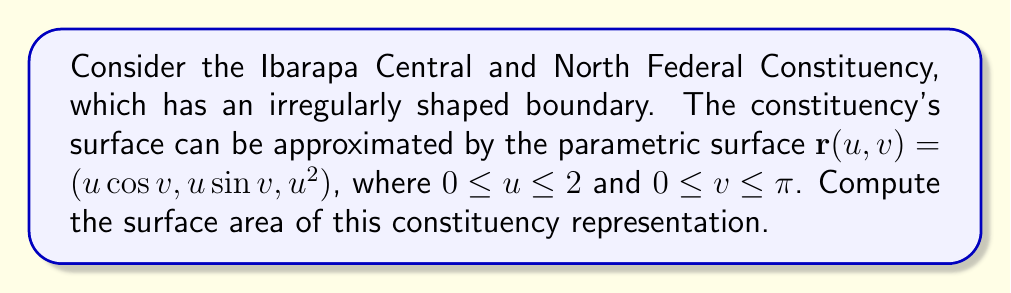Provide a solution to this math problem. To compute the surface area of the parametric surface, we follow these steps:

1) The formula for the surface area of a parametric surface is:

   $$A = \int\int_D \left|\frac{\partial \mathbf{r}}{\partial u} \times \frac{\partial \mathbf{r}}{\partial v}\right| du dv$$

2) Calculate the partial derivatives:
   
   $$\frac{\partial \mathbf{r}}{\partial u} = (\cos v, \sin v, 2u)$$
   $$\frac{\partial \mathbf{r}}{\partial v} = (-u\sin v, u\cos v, 0)$$

3) Compute the cross product:

   $$\frac{\partial \mathbf{r}}{\partial u} \times \frac{\partial \mathbf{r}}{\partial v} = (u\cos v, u\sin v, -u)$$

4) Calculate the magnitude of the cross product:

   $$\left|\frac{\partial \mathbf{r}}{\partial u} \times \frac{\partial \mathbf{r}}{\partial v}\right| = \sqrt{u^2\cos^2 v + u^2\sin^2 v + u^2} = u\sqrt{2}$$

5) Set up the double integral:

   $$A = \int_0^{\pi}\int_0^2 u\sqrt{2} du dv$$

6) Evaluate the inner integral:

   $$A = \int_0^{\pi} \left[\frac{u^2\sqrt{2}}{2}\right]_0^2 dv = \int_0^{\pi} 2\sqrt{2} dv$$

7) Evaluate the outer integral:

   $$A = 2\sqrt{2} [\pi - 0] = 2\pi\sqrt{2}$$

Therefore, the surface area of the constituency representation is $2\pi\sqrt{2}$ square units.
Answer: $2\pi\sqrt{2}$ square units 